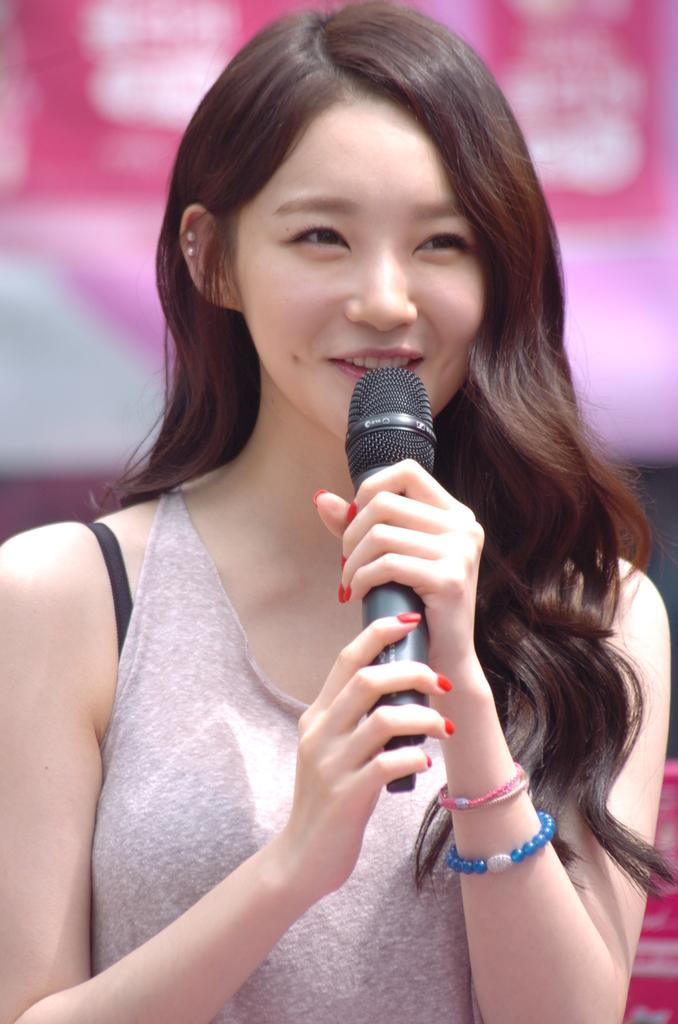Who is the main subject in the image? There is a woman in the image. What is the woman doing in the image? The woman is smiling. Can you describe the woman's hair in the image? The woman has short hair. What object is the woman holding in the image? The woman is holding a microphone. What type of celery can be seen growing in the background of the image? There is no celery present in the image; it features a woman holding a microphone. 